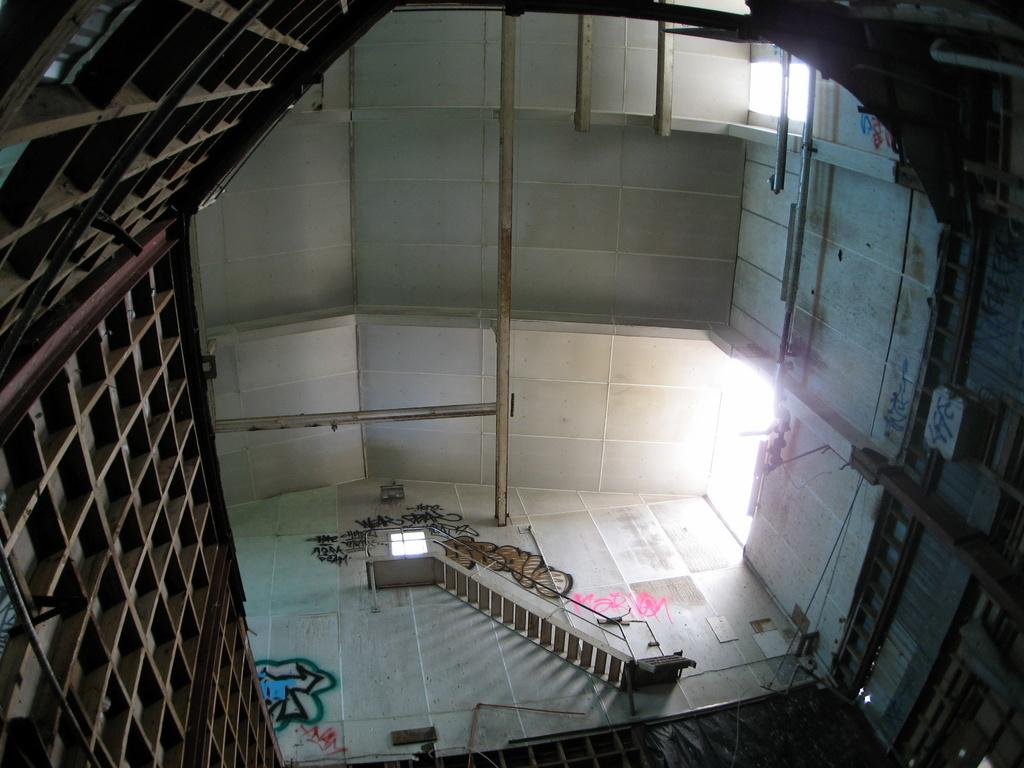What type of staircase is visible in the image? There is an iron staircase in the image. How is the iron staircase connected to the surrounding structure? The iron staircase is attached to a wall. What can be seen on the left side of the iron staircase? There are iron items on the left side of the staircase. What can be seen on the right side of the iron staircase? There are iron items on the right side of the staircase. What type of underwear is hanging on the iron staircase in the image? There is no underwear present in the image; it only features an iron staircase and iron items. 